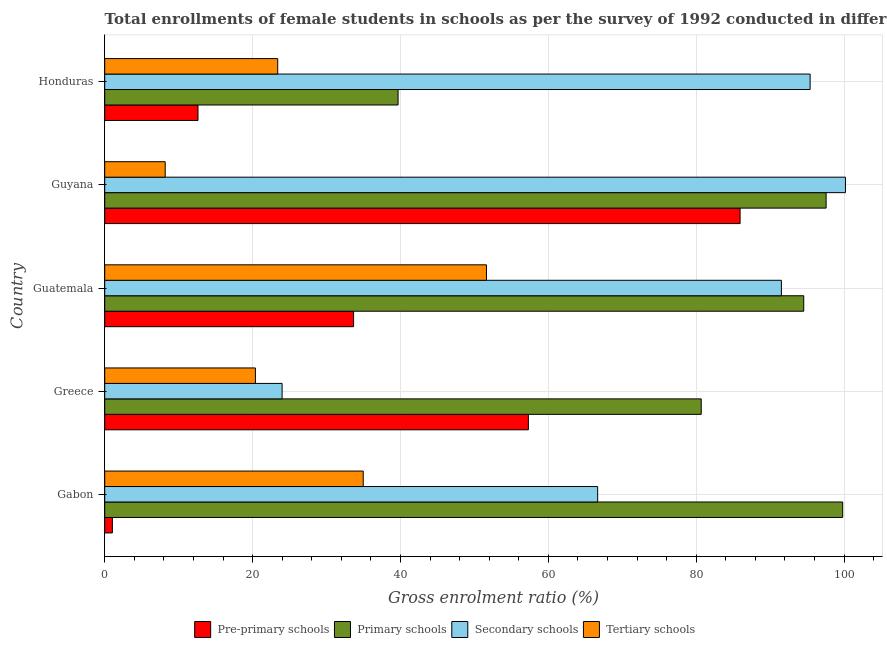How many different coloured bars are there?
Your answer should be compact. 4. How many groups of bars are there?
Provide a short and direct response. 5. Are the number of bars per tick equal to the number of legend labels?
Offer a terse response. Yes. Are the number of bars on each tick of the Y-axis equal?
Offer a very short reply. Yes. What is the label of the 2nd group of bars from the top?
Provide a succinct answer. Guyana. In how many cases, is the number of bars for a given country not equal to the number of legend labels?
Your answer should be very brief. 0. What is the gross enrolment ratio(female) in pre-primary schools in Honduras?
Offer a terse response. 12.62. Across all countries, what is the maximum gross enrolment ratio(female) in tertiary schools?
Provide a short and direct response. 51.63. Across all countries, what is the minimum gross enrolment ratio(female) in secondary schools?
Give a very brief answer. 23.99. In which country was the gross enrolment ratio(female) in pre-primary schools maximum?
Your answer should be very brief. Guyana. In which country was the gross enrolment ratio(female) in primary schools minimum?
Offer a terse response. Honduras. What is the total gross enrolment ratio(female) in secondary schools in the graph?
Provide a succinct answer. 377.79. What is the difference between the gross enrolment ratio(female) in tertiary schools in Guatemala and that in Guyana?
Ensure brevity in your answer.  43.45. What is the difference between the gross enrolment ratio(female) in pre-primary schools in Guyana and the gross enrolment ratio(female) in tertiary schools in Greece?
Give a very brief answer. 65.56. What is the average gross enrolment ratio(female) in primary schools per country?
Offer a terse response. 82.46. What is the difference between the gross enrolment ratio(female) in tertiary schools and gross enrolment ratio(female) in primary schools in Gabon?
Your response must be concise. -64.85. In how many countries, is the gross enrolment ratio(female) in secondary schools greater than 32 %?
Your answer should be very brief. 4. What is the ratio of the gross enrolment ratio(female) in secondary schools in Guatemala to that in Guyana?
Your answer should be very brief. 0.91. Is the gross enrolment ratio(female) in secondary schools in Greece less than that in Honduras?
Provide a succinct answer. Yes. What is the difference between the highest and the second highest gross enrolment ratio(female) in pre-primary schools?
Your answer should be compact. 28.64. What is the difference between the highest and the lowest gross enrolment ratio(female) in secondary schools?
Give a very brief answer. 76.2. Is the sum of the gross enrolment ratio(female) in primary schools in Guatemala and Honduras greater than the maximum gross enrolment ratio(female) in tertiary schools across all countries?
Your answer should be very brief. Yes. What does the 1st bar from the top in Guyana represents?
Give a very brief answer. Tertiary schools. What does the 1st bar from the bottom in Greece represents?
Your answer should be very brief. Pre-primary schools. Is it the case that in every country, the sum of the gross enrolment ratio(female) in pre-primary schools and gross enrolment ratio(female) in primary schools is greater than the gross enrolment ratio(female) in secondary schools?
Your answer should be very brief. No. How many bars are there?
Provide a succinct answer. 20. How many countries are there in the graph?
Keep it short and to the point. 5. Are the values on the major ticks of X-axis written in scientific E-notation?
Keep it short and to the point. No. What is the title of the graph?
Ensure brevity in your answer.  Total enrollments of female students in schools as per the survey of 1992 conducted in different countries. Does "Australia" appear as one of the legend labels in the graph?
Ensure brevity in your answer.  No. What is the label or title of the Y-axis?
Ensure brevity in your answer.  Country. What is the Gross enrolment ratio (%) in Pre-primary schools in Gabon?
Offer a terse response. 1.04. What is the Gross enrolment ratio (%) of Primary schools in Gabon?
Offer a terse response. 99.81. What is the Gross enrolment ratio (%) of Secondary schools in Gabon?
Provide a short and direct response. 66.67. What is the Gross enrolment ratio (%) of Tertiary schools in Gabon?
Your response must be concise. 34.96. What is the Gross enrolment ratio (%) in Pre-primary schools in Greece?
Make the answer very short. 57.3. What is the Gross enrolment ratio (%) in Primary schools in Greece?
Provide a short and direct response. 80.68. What is the Gross enrolment ratio (%) of Secondary schools in Greece?
Ensure brevity in your answer.  23.99. What is the Gross enrolment ratio (%) of Tertiary schools in Greece?
Your response must be concise. 20.38. What is the Gross enrolment ratio (%) of Pre-primary schools in Guatemala?
Your response must be concise. 33.66. What is the Gross enrolment ratio (%) in Primary schools in Guatemala?
Offer a very short reply. 94.55. What is the Gross enrolment ratio (%) in Secondary schools in Guatemala?
Offer a terse response. 91.52. What is the Gross enrolment ratio (%) of Tertiary schools in Guatemala?
Your response must be concise. 51.63. What is the Gross enrolment ratio (%) in Pre-primary schools in Guyana?
Your answer should be very brief. 85.94. What is the Gross enrolment ratio (%) of Primary schools in Guyana?
Make the answer very short. 97.57. What is the Gross enrolment ratio (%) of Secondary schools in Guyana?
Provide a succinct answer. 100.19. What is the Gross enrolment ratio (%) in Tertiary schools in Guyana?
Provide a succinct answer. 8.18. What is the Gross enrolment ratio (%) in Pre-primary schools in Honduras?
Your response must be concise. 12.62. What is the Gross enrolment ratio (%) in Primary schools in Honduras?
Give a very brief answer. 39.68. What is the Gross enrolment ratio (%) in Secondary schools in Honduras?
Keep it short and to the point. 95.41. What is the Gross enrolment ratio (%) of Tertiary schools in Honduras?
Offer a terse response. 23.4. Across all countries, what is the maximum Gross enrolment ratio (%) in Pre-primary schools?
Offer a terse response. 85.94. Across all countries, what is the maximum Gross enrolment ratio (%) of Primary schools?
Your answer should be very brief. 99.81. Across all countries, what is the maximum Gross enrolment ratio (%) of Secondary schools?
Your response must be concise. 100.19. Across all countries, what is the maximum Gross enrolment ratio (%) in Tertiary schools?
Ensure brevity in your answer.  51.63. Across all countries, what is the minimum Gross enrolment ratio (%) of Pre-primary schools?
Provide a short and direct response. 1.04. Across all countries, what is the minimum Gross enrolment ratio (%) of Primary schools?
Provide a succinct answer. 39.68. Across all countries, what is the minimum Gross enrolment ratio (%) of Secondary schools?
Offer a very short reply. 23.99. Across all countries, what is the minimum Gross enrolment ratio (%) of Tertiary schools?
Make the answer very short. 8.18. What is the total Gross enrolment ratio (%) of Pre-primary schools in the graph?
Offer a very short reply. 190.56. What is the total Gross enrolment ratio (%) in Primary schools in the graph?
Your answer should be compact. 412.29. What is the total Gross enrolment ratio (%) of Secondary schools in the graph?
Provide a succinct answer. 377.79. What is the total Gross enrolment ratio (%) in Tertiary schools in the graph?
Offer a very short reply. 138.56. What is the difference between the Gross enrolment ratio (%) of Pre-primary schools in Gabon and that in Greece?
Ensure brevity in your answer.  -56.27. What is the difference between the Gross enrolment ratio (%) in Primary schools in Gabon and that in Greece?
Your answer should be compact. 19.13. What is the difference between the Gross enrolment ratio (%) of Secondary schools in Gabon and that in Greece?
Provide a succinct answer. 42.68. What is the difference between the Gross enrolment ratio (%) of Tertiary schools in Gabon and that in Greece?
Keep it short and to the point. 14.58. What is the difference between the Gross enrolment ratio (%) in Pre-primary schools in Gabon and that in Guatemala?
Your answer should be compact. -32.63. What is the difference between the Gross enrolment ratio (%) of Primary schools in Gabon and that in Guatemala?
Ensure brevity in your answer.  5.27. What is the difference between the Gross enrolment ratio (%) of Secondary schools in Gabon and that in Guatemala?
Your answer should be compact. -24.85. What is the difference between the Gross enrolment ratio (%) in Tertiary schools in Gabon and that in Guatemala?
Your answer should be compact. -16.67. What is the difference between the Gross enrolment ratio (%) in Pre-primary schools in Gabon and that in Guyana?
Offer a terse response. -84.9. What is the difference between the Gross enrolment ratio (%) in Primary schools in Gabon and that in Guyana?
Your answer should be very brief. 2.24. What is the difference between the Gross enrolment ratio (%) in Secondary schools in Gabon and that in Guyana?
Provide a short and direct response. -33.52. What is the difference between the Gross enrolment ratio (%) of Tertiary schools in Gabon and that in Guyana?
Offer a terse response. 26.78. What is the difference between the Gross enrolment ratio (%) in Pre-primary schools in Gabon and that in Honduras?
Your response must be concise. -11.58. What is the difference between the Gross enrolment ratio (%) of Primary schools in Gabon and that in Honduras?
Keep it short and to the point. 60.14. What is the difference between the Gross enrolment ratio (%) in Secondary schools in Gabon and that in Honduras?
Your answer should be very brief. -28.74. What is the difference between the Gross enrolment ratio (%) in Tertiary schools in Gabon and that in Honduras?
Offer a terse response. 11.57. What is the difference between the Gross enrolment ratio (%) in Pre-primary schools in Greece and that in Guatemala?
Ensure brevity in your answer.  23.64. What is the difference between the Gross enrolment ratio (%) of Primary schools in Greece and that in Guatemala?
Your response must be concise. -13.87. What is the difference between the Gross enrolment ratio (%) of Secondary schools in Greece and that in Guatemala?
Your response must be concise. -67.53. What is the difference between the Gross enrolment ratio (%) in Tertiary schools in Greece and that in Guatemala?
Your answer should be very brief. -31.25. What is the difference between the Gross enrolment ratio (%) in Pre-primary schools in Greece and that in Guyana?
Provide a succinct answer. -28.64. What is the difference between the Gross enrolment ratio (%) of Primary schools in Greece and that in Guyana?
Give a very brief answer. -16.89. What is the difference between the Gross enrolment ratio (%) of Secondary schools in Greece and that in Guyana?
Your answer should be compact. -76.2. What is the difference between the Gross enrolment ratio (%) in Tertiary schools in Greece and that in Guyana?
Give a very brief answer. 12.2. What is the difference between the Gross enrolment ratio (%) of Pre-primary schools in Greece and that in Honduras?
Provide a short and direct response. 44.69. What is the difference between the Gross enrolment ratio (%) of Primary schools in Greece and that in Honduras?
Offer a terse response. 41. What is the difference between the Gross enrolment ratio (%) of Secondary schools in Greece and that in Honduras?
Offer a very short reply. -71.42. What is the difference between the Gross enrolment ratio (%) of Tertiary schools in Greece and that in Honduras?
Keep it short and to the point. -3.02. What is the difference between the Gross enrolment ratio (%) in Pre-primary schools in Guatemala and that in Guyana?
Provide a short and direct response. -52.28. What is the difference between the Gross enrolment ratio (%) in Primary schools in Guatemala and that in Guyana?
Keep it short and to the point. -3.03. What is the difference between the Gross enrolment ratio (%) in Secondary schools in Guatemala and that in Guyana?
Your response must be concise. -8.66. What is the difference between the Gross enrolment ratio (%) in Tertiary schools in Guatemala and that in Guyana?
Offer a terse response. 43.45. What is the difference between the Gross enrolment ratio (%) of Pre-primary schools in Guatemala and that in Honduras?
Keep it short and to the point. 21.05. What is the difference between the Gross enrolment ratio (%) in Primary schools in Guatemala and that in Honduras?
Ensure brevity in your answer.  54.87. What is the difference between the Gross enrolment ratio (%) of Secondary schools in Guatemala and that in Honduras?
Provide a succinct answer. -3.89. What is the difference between the Gross enrolment ratio (%) of Tertiary schools in Guatemala and that in Honduras?
Your answer should be compact. 28.23. What is the difference between the Gross enrolment ratio (%) in Pre-primary schools in Guyana and that in Honduras?
Provide a short and direct response. 73.32. What is the difference between the Gross enrolment ratio (%) of Primary schools in Guyana and that in Honduras?
Provide a succinct answer. 57.89. What is the difference between the Gross enrolment ratio (%) in Secondary schools in Guyana and that in Honduras?
Make the answer very short. 4.78. What is the difference between the Gross enrolment ratio (%) of Tertiary schools in Guyana and that in Honduras?
Your answer should be very brief. -15.22. What is the difference between the Gross enrolment ratio (%) of Pre-primary schools in Gabon and the Gross enrolment ratio (%) of Primary schools in Greece?
Provide a short and direct response. -79.64. What is the difference between the Gross enrolment ratio (%) of Pre-primary schools in Gabon and the Gross enrolment ratio (%) of Secondary schools in Greece?
Keep it short and to the point. -22.96. What is the difference between the Gross enrolment ratio (%) in Pre-primary schools in Gabon and the Gross enrolment ratio (%) in Tertiary schools in Greece?
Offer a terse response. -19.35. What is the difference between the Gross enrolment ratio (%) of Primary schools in Gabon and the Gross enrolment ratio (%) of Secondary schools in Greece?
Your answer should be compact. 75.82. What is the difference between the Gross enrolment ratio (%) in Primary schools in Gabon and the Gross enrolment ratio (%) in Tertiary schools in Greece?
Your response must be concise. 79.43. What is the difference between the Gross enrolment ratio (%) of Secondary schools in Gabon and the Gross enrolment ratio (%) of Tertiary schools in Greece?
Provide a short and direct response. 46.29. What is the difference between the Gross enrolment ratio (%) of Pre-primary schools in Gabon and the Gross enrolment ratio (%) of Primary schools in Guatemala?
Give a very brief answer. -93.51. What is the difference between the Gross enrolment ratio (%) of Pre-primary schools in Gabon and the Gross enrolment ratio (%) of Secondary schools in Guatemala?
Keep it short and to the point. -90.49. What is the difference between the Gross enrolment ratio (%) of Pre-primary schools in Gabon and the Gross enrolment ratio (%) of Tertiary schools in Guatemala?
Offer a very short reply. -50.6. What is the difference between the Gross enrolment ratio (%) of Primary schools in Gabon and the Gross enrolment ratio (%) of Secondary schools in Guatemala?
Offer a terse response. 8.29. What is the difference between the Gross enrolment ratio (%) of Primary schools in Gabon and the Gross enrolment ratio (%) of Tertiary schools in Guatemala?
Your answer should be compact. 48.18. What is the difference between the Gross enrolment ratio (%) of Secondary schools in Gabon and the Gross enrolment ratio (%) of Tertiary schools in Guatemala?
Offer a very short reply. 15.04. What is the difference between the Gross enrolment ratio (%) of Pre-primary schools in Gabon and the Gross enrolment ratio (%) of Primary schools in Guyana?
Offer a terse response. -96.54. What is the difference between the Gross enrolment ratio (%) of Pre-primary schools in Gabon and the Gross enrolment ratio (%) of Secondary schools in Guyana?
Provide a short and direct response. -99.15. What is the difference between the Gross enrolment ratio (%) of Pre-primary schools in Gabon and the Gross enrolment ratio (%) of Tertiary schools in Guyana?
Offer a terse response. -7.14. What is the difference between the Gross enrolment ratio (%) of Primary schools in Gabon and the Gross enrolment ratio (%) of Secondary schools in Guyana?
Give a very brief answer. -0.37. What is the difference between the Gross enrolment ratio (%) in Primary schools in Gabon and the Gross enrolment ratio (%) in Tertiary schools in Guyana?
Keep it short and to the point. 91.63. What is the difference between the Gross enrolment ratio (%) in Secondary schools in Gabon and the Gross enrolment ratio (%) in Tertiary schools in Guyana?
Your response must be concise. 58.49. What is the difference between the Gross enrolment ratio (%) in Pre-primary schools in Gabon and the Gross enrolment ratio (%) in Primary schools in Honduras?
Provide a succinct answer. -38.64. What is the difference between the Gross enrolment ratio (%) in Pre-primary schools in Gabon and the Gross enrolment ratio (%) in Secondary schools in Honduras?
Ensure brevity in your answer.  -94.37. What is the difference between the Gross enrolment ratio (%) of Pre-primary schools in Gabon and the Gross enrolment ratio (%) of Tertiary schools in Honduras?
Your response must be concise. -22.36. What is the difference between the Gross enrolment ratio (%) of Primary schools in Gabon and the Gross enrolment ratio (%) of Secondary schools in Honduras?
Make the answer very short. 4.4. What is the difference between the Gross enrolment ratio (%) of Primary schools in Gabon and the Gross enrolment ratio (%) of Tertiary schools in Honduras?
Your answer should be compact. 76.42. What is the difference between the Gross enrolment ratio (%) of Secondary schools in Gabon and the Gross enrolment ratio (%) of Tertiary schools in Honduras?
Give a very brief answer. 43.27. What is the difference between the Gross enrolment ratio (%) in Pre-primary schools in Greece and the Gross enrolment ratio (%) in Primary schools in Guatemala?
Provide a succinct answer. -37.24. What is the difference between the Gross enrolment ratio (%) of Pre-primary schools in Greece and the Gross enrolment ratio (%) of Secondary schools in Guatemala?
Ensure brevity in your answer.  -34.22. What is the difference between the Gross enrolment ratio (%) of Pre-primary schools in Greece and the Gross enrolment ratio (%) of Tertiary schools in Guatemala?
Your answer should be very brief. 5.67. What is the difference between the Gross enrolment ratio (%) in Primary schools in Greece and the Gross enrolment ratio (%) in Secondary schools in Guatemala?
Give a very brief answer. -10.84. What is the difference between the Gross enrolment ratio (%) in Primary schools in Greece and the Gross enrolment ratio (%) in Tertiary schools in Guatemala?
Give a very brief answer. 29.05. What is the difference between the Gross enrolment ratio (%) of Secondary schools in Greece and the Gross enrolment ratio (%) of Tertiary schools in Guatemala?
Keep it short and to the point. -27.64. What is the difference between the Gross enrolment ratio (%) of Pre-primary schools in Greece and the Gross enrolment ratio (%) of Primary schools in Guyana?
Your answer should be very brief. -40.27. What is the difference between the Gross enrolment ratio (%) of Pre-primary schools in Greece and the Gross enrolment ratio (%) of Secondary schools in Guyana?
Provide a succinct answer. -42.89. What is the difference between the Gross enrolment ratio (%) of Pre-primary schools in Greece and the Gross enrolment ratio (%) of Tertiary schools in Guyana?
Provide a succinct answer. 49.12. What is the difference between the Gross enrolment ratio (%) in Primary schools in Greece and the Gross enrolment ratio (%) in Secondary schools in Guyana?
Give a very brief answer. -19.51. What is the difference between the Gross enrolment ratio (%) in Primary schools in Greece and the Gross enrolment ratio (%) in Tertiary schools in Guyana?
Offer a terse response. 72.5. What is the difference between the Gross enrolment ratio (%) in Secondary schools in Greece and the Gross enrolment ratio (%) in Tertiary schools in Guyana?
Your answer should be compact. 15.81. What is the difference between the Gross enrolment ratio (%) in Pre-primary schools in Greece and the Gross enrolment ratio (%) in Primary schools in Honduras?
Your response must be concise. 17.62. What is the difference between the Gross enrolment ratio (%) in Pre-primary schools in Greece and the Gross enrolment ratio (%) in Secondary schools in Honduras?
Provide a succinct answer. -38.11. What is the difference between the Gross enrolment ratio (%) of Pre-primary schools in Greece and the Gross enrolment ratio (%) of Tertiary schools in Honduras?
Give a very brief answer. 33.9. What is the difference between the Gross enrolment ratio (%) in Primary schools in Greece and the Gross enrolment ratio (%) in Secondary schools in Honduras?
Your answer should be very brief. -14.73. What is the difference between the Gross enrolment ratio (%) of Primary schools in Greece and the Gross enrolment ratio (%) of Tertiary schools in Honduras?
Offer a terse response. 57.28. What is the difference between the Gross enrolment ratio (%) of Secondary schools in Greece and the Gross enrolment ratio (%) of Tertiary schools in Honduras?
Your response must be concise. 0.59. What is the difference between the Gross enrolment ratio (%) of Pre-primary schools in Guatemala and the Gross enrolment ratio (%) of Primary schools in Guyana?
Your answer should be compact. -63.91. What is the difference between the Gross enrolment ratio (%) of Pre-primary schools in Guatemala and the Gross enrolment ratio (%) of Secondary schools in Guyana?
Make the answer very short. -66.53. What is the difference between the Gross enrolment ratio (%) of Pre-primary schools in Guatemala and the Gross enrolment ratio (%) of Tertiary schools in Guyana?
Offer a very short reply. 25.48. What is the difference between the Gross enrolment ratio (%) of Primary schools in Guatemala and the Gross enrolment ratio (%) of Secondary schools in Guyana?
Keep it short and to the point. -5.64. What is the difference between the Gross enrolment ratio (%) of Primary schools in Guatemala and the Gross enrolment ratio (%) of Tertiary schools in Guyana?
Give a very brief answer. 86.37. What is the difference between the Gross enrolment ratio (%) of Secondary schools in Guatemala and the Gross enrolment ratio (%) of Tertiary schools in Guyana?
Your answer should be very brief. 83.34. What is the difference between the Gross enrolment ratio (%) of Pre-primary schools in Guatemala and the Gross enrolment ratio (%) of Primary schools in Honduras?
Provide a succinct answer. -6.02. What is the difference between the Gross enrolment ratio (%) in Pre-primary schools in Guatemala and the Gross enrolment ratio (%) in Secondary schools in Honduras?
Ensure brevity in your answer.  -61.75. What is the difference between the Gross enrolment ratio (%) in Pre-primary schools in Guatemala and the Gross enrolment ratio (%) in Tertiary schools in Honduras?
Offer a very short reply. 10.26. What is the difference between the Gross enrolment ratio (%) of Primary schools in Guatemala and the Gross enrolment ratio (%) of Secondary schools in Honduras?
Keep it short and to the point. -0.86. What is the difference between the Gross enrolment ratio (%) in Primary schools in Guatemala and the Gross enrolment ratio (%) in Tertiary schools in Honduras?
Keep it short and to the point. 71.15. What is the difference between the Gross enrolment ratio (%) of Secondary schools in Guatemala and the Gross enrolment ratio (%) of Tertiary schools in Honduras?
Offer a terse response. 68.13. What is the difference between the Gross enrolment ratio (%) of Pre-primary schools in Guyana and the Gross enrolment ratio (%) of Primary schools in Honduras?
Make the answer very short. 46.26. What is the difference between the Gross enrolment ratio (%) of Pre-primary schools in Guyana and the Gross enrolment ratio (%) of Secondary schools in Honduras?
Offer a very short reply. -9.47. What is the difference between the Gross enrolment ratio (%) of Pre-primary schools in Guyana and the Gross enrolment ratio (%) of Tertiary schools in Honduras?
Provide a short and direct response. 62.54. What is the difference between the Gross enrolment ratio (%) of Primary schools in Guyana and the Gross enrolment ratio (%) of Secondary schools in Honduras?
Make the answer very short. 2.16. What is the difference between the Gross enrolment ratio (%) of Primary schools in Guyana and the Gross enrolment ratio (%) of Tertiary schools in Honduras?
Offer a very short reply. 74.17. What is the difference between the Gross enrolment ratio (%) in Secondary schools in Guyana and the Gross enrolment ratio (%) in Tertiary schools in Honduras?
Offer a terse response. 76.79. What is the average Gross enrolment ratio (%) of Pre-primary schools per country?
Provide a succinct answer. 38.11. What is the average Gross enrolment ratio (%) of Primary schools per country?
Your response must be concise. 82.46. What is the average Gross enrolment ratio (%) of Secondary schools per country?
Provide a succinct answer. 75.56. What is the average Gross enrolment ratio (%) of Tertiary schools per country?
Provide a succinct answer. 27.71. What is the difference between the Gross enrolment ratio (%) of Pre-primary schools and Gross enrolment ratio (%) of Primary schools in Gabon?
Make the answer very short. -98.78. What is the difference between the Gross enrolment ratio (%) of Pre-primary schools and Gross enrolment ratio (%) of Secondary schools in Gabon?
Offer a terse response. -65.64. What is the difference between the Gross enrolment ratio (%) of Pre-primary schools and Gross enrolment ratio (%) of Tertiary schools in Gabon?
Offer a terse response. -33.93. What is the difference between the Gross enrolment ratio (%) in Primary schools and Gross enrolment ratio (%) in Secondary schools in Gabon?
Offer a terse response. 33.14. What is the difference between the Gross enrolment ratio (%) of Primary schools and Gross enrolment ratio (%) of Tertiary schools in Gabon?
Your response must be concise. 64.85. What is the difference between the Gross enrolment ratio (%) of Secondary schools and Gross enrolment ratio (%) of Tertiary schools in Gabon?
Provide a short and direct response. 31.71. What is the difference between the Gross enrolment ratio (%) in Pre-primary schools and Gross enrolment ratio (%) in Primary schools in Greece?
Keep it short and to the point. -23.38. What is the difference between the Gross enrolment ratio (%) of Pre-primary schools and Gross enrolment ratio (%) of Secondary schools in Greece?
Your answer should be very brief. 33.31. What is the difference between the Gross enrolment ratio (%) in Pre-primary schools and Gross enrolment ratio (%) in Tertiary schools in Greece?
Your answer should be compact. 36.92. What is the difference between the Gross enrolment ratio (%) of Primary schools and Gross enrolment ratio (%) of Secondary schools in Greece?
Make the answer very short. 56.69. What is the difference between the Gross enrolment ratio (%) in Primary schools and Gross enrolment ratio (%) in Tertiary schools in Greece?
Provide a short and direct response. 60.3. What is the difference between the Gross enrolment ratio (%) of Secondary schools and Gross enrolment ratio (%) of Tertiary schools in Greece?
Keep it short and to the point. 3.61. What is the difference between the Gross enrolment ratio (%) in Pre-primary schools and Gross enrolment ratio (%) in Primary schools in Guatemala?
Provide a short and direct response. -60.88. What is the difference between the Gross enrolment ratio (%) of Pre-primary schools and Gross enrolment ratio (%) of Secondary schools in Guatemala?
Offer a terse response. -57.86. What is the difference between the Gross enrolment ratio (%) of Pre-primary schools and Gross enrolment ratio (%) of Tertiary schools in Guatemala?
Your answer should be compact. -17.97. What is the difference between the Gross enrolment ratio (%) of Primary schools and Gross enrolment ratio (%) of Secondary schools in Guatemala?
Keep it short and to the point. 3.02. What is the difference between the Gross enrolment ratio (%) in Primary schools and Gross enrolment ratio (%) in Tertiary schools in Guatemala?
Ensure brevity in your answer.  42.91. What is the difference between the Gross enrolment ratio (%) in Secondary schools and Gross enrolment ratio (%) in Tertiary schools in Guatemala?
Your answer should be compact. 39.89. What is the difference between the Gross enrolment ratio (%) in Pre-primary schools and Gross enrolment ratio (%) in Primary schools in Guyana?
Offer a very short reply. -11.63. What is the difference between the Gross enrolment ratio (%) of Pre-primary schools and Gross enrolment ratio (%) of Secondary schools in Guyana?
Provide a succinct answer. -14.25. What is the difference between the Gross enrolment ratio (%) in Pre-primary schools and Gross enrolment ratio (%) in Tertiary schools in Guyana?
Provide a short and direct response. 77.76. What is the difference between the Gross enrolment ratio (%) of Primary schools and Gross enrolment ratio (%) of Secondary schools in Guyana?
Ensure brevity in your answer.  -2.62. What is the difference between the Gross enrolment ratio (%) in Primary schools and Gross enrolment ratio (%) in Tertiary schools in Guyana?
Keep it short and to the point. 89.39. What is the difference between the Gross enrolment ratio (%) in Secondary schools and Gross enrolment ratio (%) in Tertiary schools in Guyana?
Provide a short and direct response. 92.01. What is the difference between the Gross enrolment ratio (%) of Pre-primary schools and Gross enrolment ratio (%) of Primary schools in Honduras?
Provide a short and direct response. -27.06. What is the difference between the Gross enrolment ratio (%) in Pre-primary schools and Gross enrolment ratio (%) in Secondary schools in Honduras?
Give a very brief answer. -82.79. What is the difference between the Gross enrolment ratio (%) in Pre-primary schools and Gross enrolment ratio (%) in Tertiary schools in Honduras?
Provide a short and direct response. -10.78. What is the difference between the Gross enrolment ratio (%) of Primary schools and Gross enrolment ratio (%) of Secondary schools in Honduras?
Offer a terse response. -55.73. What is the difference between the Gross enrolment ratio (%) of Primary schools and Gross enrolment ratio (%) of Tertiary schools in Honduras?
Your response must be concise. 16.28. What is the difference between the Gross enrolment ratio (%) of Secondary schools and Gross enrolment ratio (%) of Tertiary schools in Honduras?
Your answer should be compact. 72.01. What is the ratio of the Gross enrolment ratio (%) of Pre-primary schools in Gabon to that in Greece?
Your answer should be very brief. 0.02. What is the ratio of the Gross enrolment ratio (%) in Primary schools in Gabon to that in Greece?
Your answer should be very brief. 1.24. What is the ratio of the Gross enrolment ratio (%) in Secondary schools in Gabon to that in Greece?
Provide a succinct answer. 2.78. What is the ratio of the Gross enrolment ratio (%) in Tertiary schools in Gabon to that in Greece?
Make the answer very short. 1.72. What is the ratio of the Gross enrolment ratio (%) of Pre-primary schools in Gabon to that in Guatemala?
Your response must be concise. 0.03. What is the ratio of the Gross enrolment ratio (%) in Primary schools in Gabon to that in Guatemala?
Ensure brevity in your answer.  1.06. What is the ratio of the Gross enrolment ratio (%) of Secondary schools in Gabon to that in Guatemala?
Your answer should be compact. 0.73. What is the ratio of the Gross enrolment ratio (%) of Tertiary schools in Gabon to that in Guatemala?
Provide a short and direct response. 0.68. What is the ratio of the Gross enrolment ratio (%) of Pre-primary schools in Gabon to that in Guyana?
Your response must be concise. 0.01. What is the ratio of the Gross enrolment ratio (%) of Primary schools in Gabon to that in Guyana?
Keep it short and to the point. 1.02. What is the ratio of the Gross enrolment ratio (%) in Secondary schools in Gabon to that in Guyana?
Your answer should be very brief. 0.67. What is the ratio of the Gross enrolment ratio (%) in Tertiary schools in Gabon to that in Guyana?
Make the answer very short. 4.27. What is the ratio of the Gross enrolment ratio (%) in Pre-primary schools in Gabon to that in Honduras?
Your response must be concise. 0.08. What is the ratio of the Gross enrolment ratio (%) in Primary schools in Gabon to that in Honduras?
Ensure brevity in your answer.  2.52. What is the ratio of the Gross enrolment ratio (%) of Secondary schools in Gabon to that in Honduras?
Make the answer very short. 0.7. What is the ratio of the Gross enrolment ratio (%) in Tertiary schools in Gabon to that in Honduras?
Your answer should be very brief. 1.49. What is the ratio of the Gross enrolment ratio (%) in Pre-primary schools in Greece to that in Guatemala?
Your answer should be very brief. 1.7. What is the ratio of the Gross enrolment ratio (%) of Primary schools in Greece to that in Guatemala?
Offer a terse response. 0.85. What is the ratio of the Gross enrolment ratio (%) of Secondary schools in Greece to that in Guatemala?
Offer a terse response. 0.26. What is the ratio of the Gross enrolment ratio (%) of Tertiary schools in Greece to that in Guatemala?
Make the answer very short. 0.39. What is the ratio of the Gross enrolment ratio (%) of Pre-primary schools in Greece to that in Guyana?
Your answer should be very brief. 0.67. What is the ratio of the Gross enrolment ratio (%) in Primary schools in Greece to that in Guyana?
Make the answer very short. 0.83. What is the ratio of the Gross enrolment ratio (%) of Secondary schools in Greece to that in Guyana?
Offer a terse response. 0.24. What is the ratio of the Gross enrolment ratio (%) of Tertiary schools in Greece to that in Guyana?
Provide a short and direct response. 2.49. What is the ratio of the Gross enrolment ratio (%) in Pre-primary schools in Greece to that in Honduras?
Your response must be concise. 4.54. What is the ratio of the Gross enrolment ratio (%) in Primary schools in Greece to that in Honduras?
Offer a terse response. 2.03. What is the ratio of the Gross enrolment ratio (%) in Secondary schools in Greece to that in Honduras?
Your answer should be compact. 0.25. What is the ratio of the Gross enrolment ratio (%) of Tertiary schools in Greece to that in Honduras?
Offer a very short reply. 0.87. What is the ratio of the Gross enrolment ratio (%) of Pre-primary schools in Guatemala to that in Guyana?
Provide a short and direct response. 0.39. What is the ratio of the Gross enrolment ratio (%) of Primary schools in Guatemala to that in Guyana?
Ensure brevity in your answer.  0.97. What is the ratio of the Gross enrolment ratio (%) in Secondary schools in Guatemala to that in Guyana?
Ensure brevity in your answer.  0.91. What is the ratio of the Gross enrolment ratio (%) in Tertiary schools in Guatemala to that in Guyana?
Your answer should be compact. 6.31. What is the ratio of the Gross enrolment ratio (%) of Pre-primary schools in Guatemala to that in Honduras?
Your answer should be very brief. 2.67. What is the ratio of the Gross enrolment ratio (%) in Primary schools in Guatemala to that in Honduras?
Make the answer very short. 2.38. What is the ratio of the Gross enrolment ratio (%) of Secondary schools in Guatemala to that in Honduras?
Offer a terse response. 0.96. What is the ratio of the Gross enrolment ratio (%) of Tertiary schools in Guatemala to that in Honduras?
Make the answer very short. 2.21. What is the ratio of the Gross enrolment ratio (%) in Pre-primary schools in Guyana to that in Honduras?
Keep it short and to the point. 6.81. What is the ratio of the Gross enrolment ratio (%) in Primary schools in Guyana to that in Honduras?
Provide a short and direct response. 2.46. What is the ratio of the Gross enrolment ratio (%) in Secondary schools in Guyana to that in Honduras?
Provide a succinct answer. 1.05. What is the ratio of the Gross enrolment ratio (%) of Tertiary schools in Guyana to that in Honduras?
Offer a very short reply. 0.35. What is the difference between the highest and the second highest Gross enrolment ratio (%) of Pre-primary schools?
Your answer should be compact. 28.64. What is the difference between the highest and the second highest Gross enrolment ratio (%) of Primary schools?
Your response must be concise. 2.24. What is the difference between the highest and the second highest Gross enrolment ratio (%) of Secondary schools?
Your answer should be very brief. 4.78. What is the difference between the highest and the second highest Gross enrolment ratio (%) of Tertiary schools?
Make the answer very short. 16.67. What is the difference between the highest and the lowest Gross enrolment ratio (%) in Pre-primary schools?
Provide a succinct answer. 84.9. What is the difference between the highest and the lowest Gross enrolment ratio (%) in Primary schools?
Your answer should be compact. 60.14. What is the difference between the highest and the lowest Gross enrolment ratio (%) of Secondary schools?
Ensure brevity in your answer.  76.2. What is the difference between the highest and the lowest Gross enrolment ratio (%) of Tertiary schools?
Keep it short and to the point. 43.45. 